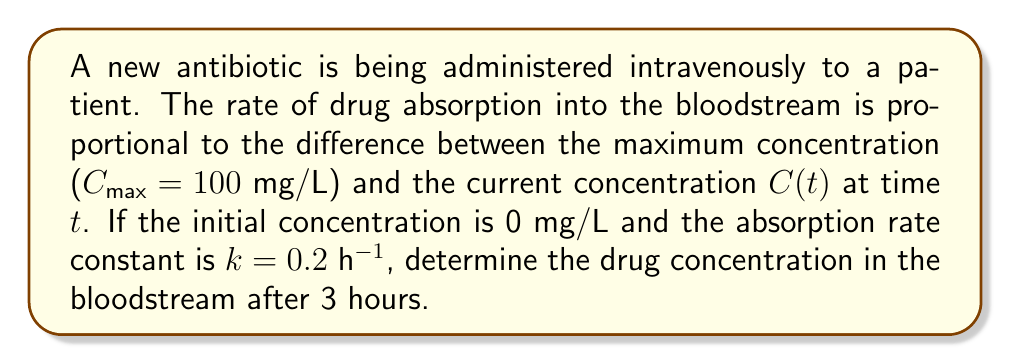Teach me how to tackle this problem. 1) Let's start with the differential equation that describes the rate of change of drug concentration:

   $$\frac{dC}{dt} = k(C_{max} - C)$$

   where $C$ is the drug concentration, $t$ is time, $k$ is the absorption rate constant, and $C_{max}$ is the maximum concentration.

2) We can solve this first-order linear differential equation using separation of variables:

   $$\frac{dC}{C_{max} - C} = k dt$$

3) Integrating both sides:

   $$\int \frac{dC}{C_{max} - C} = \int k dt$$

   $$-\ln|C_{max} - C| = kt + A$$

   where $A$ is the constant of integration.

4) Solving for $C$:

   $$C_{max} - C = e^{-(kt + A)}$$
   $$C = C_{max} - Be^{-kt}$$

   where $B = e^A$ is a new constant.

5) Using the initial condition $C(0) = 0$:

   $$0 = C_{max} - B$$
   $$B = C_{max} = 100$$

6) Therefore, our solution is:

   $$C(t) = C_{max}(1 - e^{-kt})$$

7) Substituting the given values ($C_{max} = 100$ mg/L, $k = 0.2$ h^(-1), $t = 3$ h):

   $$C(3) = 100(1 - e^{-0.2 * 3})$$
   $$C(3) = 100(1 - e^{-0.6})$$
   $$C(3) = 100(1 - 0.5488)$$
   $$C(3) = 45.12$$ mg/L
Answer: 45.12 mg/L 